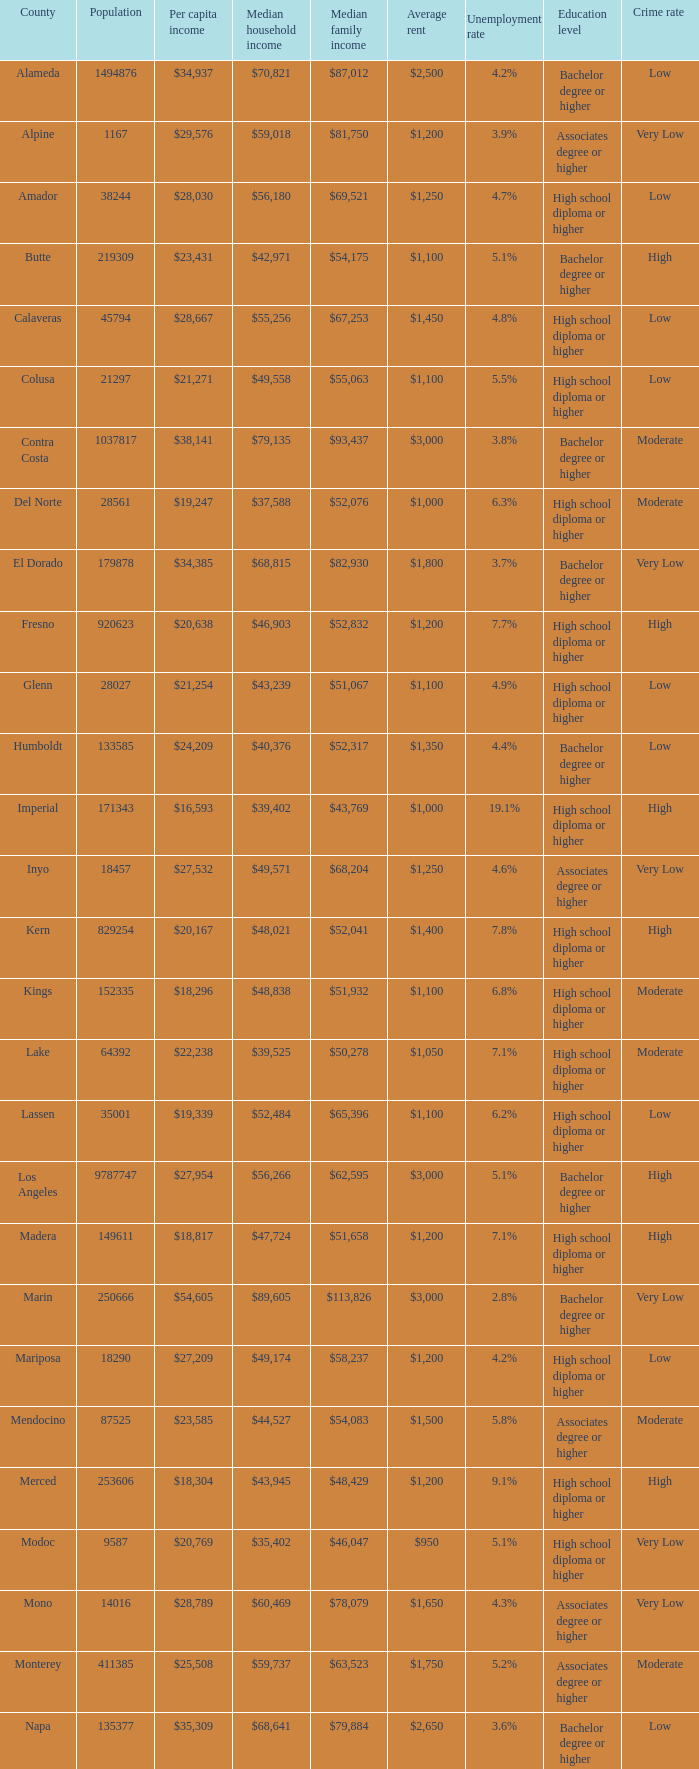Identify the middle family earnings in riverside. $65,457. 